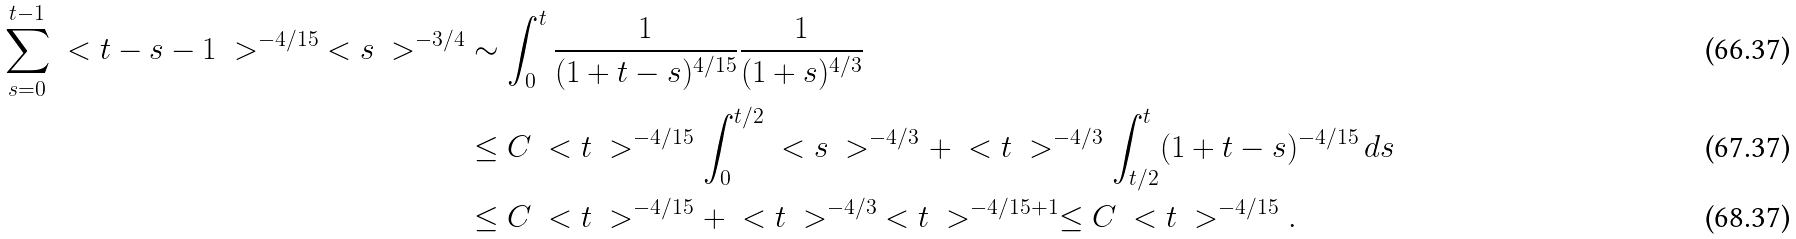<formula> <loc_0><loc_0><loc_500><loc_500>\sum _ { s = 0 } ^ { t - 1 } \ < t - s - 1 \ > ^ { - 4 / 1 5 } \ < s \ > ^ { - 3 / 4 } & \sim \int _ { 0 } ^ { t } \frac { 1 } { ( 1 + t - s ) ^ { 4 / 1 5 } } \frac { 1 } { ( 1 + s ) ^ { 4 / 3 } } \\ & \leq C \ < t \ > ^ { - 4 / 1 5 } \int _ { 0 } ^ { t / 2 } \ < s \ > ^ { - 4 / 3 } + \ < t \ > ^ { - 4 / 3 } \int _ { t / 2 } ^ { t } ( 1 + t - s ) ^ { - 4 / 1 5 } \, d s \\ & \leq C \ < t \ > ^ { - 4 / 1 5 } + \ < t \ > ^ { - 4 / 3 } \ < t \ > ^ { - 4 / 1 5 + 1 } \leq C \ < t \ > ^ { - 4 / 1 5 } .</formula> 